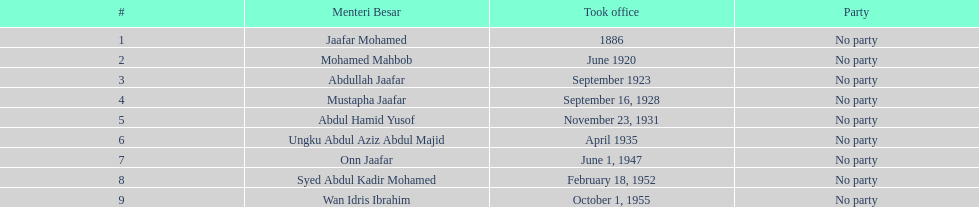What was the length of ungku abdul aziz abdul majid's service? 12 years. 